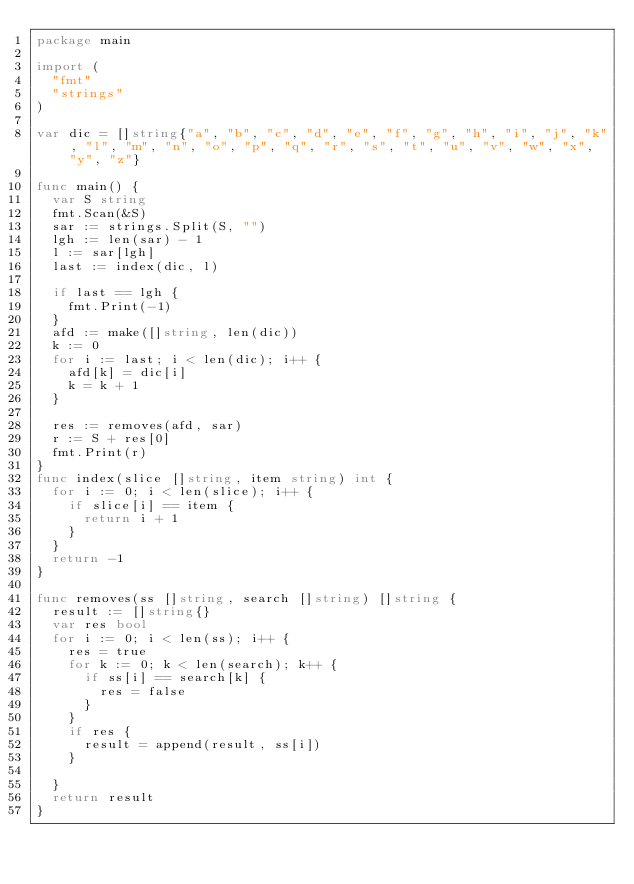<code> <loc_0><loc_0><loc_500><loc_500><_Go_>package main

import (
	"fmt"
	"strings"
)

var dic = []string{"a", "b", "c", "d", "e", "f", "g", "h", "i", "j", "k", "l", "m", "n", "o", "p", "q", "r", "s", "t", "u", "v", "w", "x", "y", "z"}

func main() {
	var S string
	fmt.Scan(&S)
	sar := strings.Split(S, "")
	lgh := len(sar) - 1
	l := sar[lgh]
	last := index(dic, l)

	if last == lgh {
		fmt.Print(-1)
	}
	afd := make([]string, len(dic))
	k := 0
	for i := last; i < len(dic); i++ {
		afd[k] = dic[i]
		k = k + 1
	}

	res := removes(afd, sar)
	r := S + res[0]
	fmt.Print(r)
}
func index(slice []string, item string) int {
	for i := 0; i < len(slice); i++ {
		if slice[i] == item {
			return i + 1
		}
	}
	return -1
}

func removes(ss []string, search []string) []string {
	result := []string{}
	var res bool
	for i := 0; i < len(ss); i++ {
		res = true
		for k := 0; k < len(search); k++ {
			if ss[i] == search[k] {
				res = false
			}
		}
		if res {
			result = append(result, ss[i])
		}

	}
	return result
}
</code> 